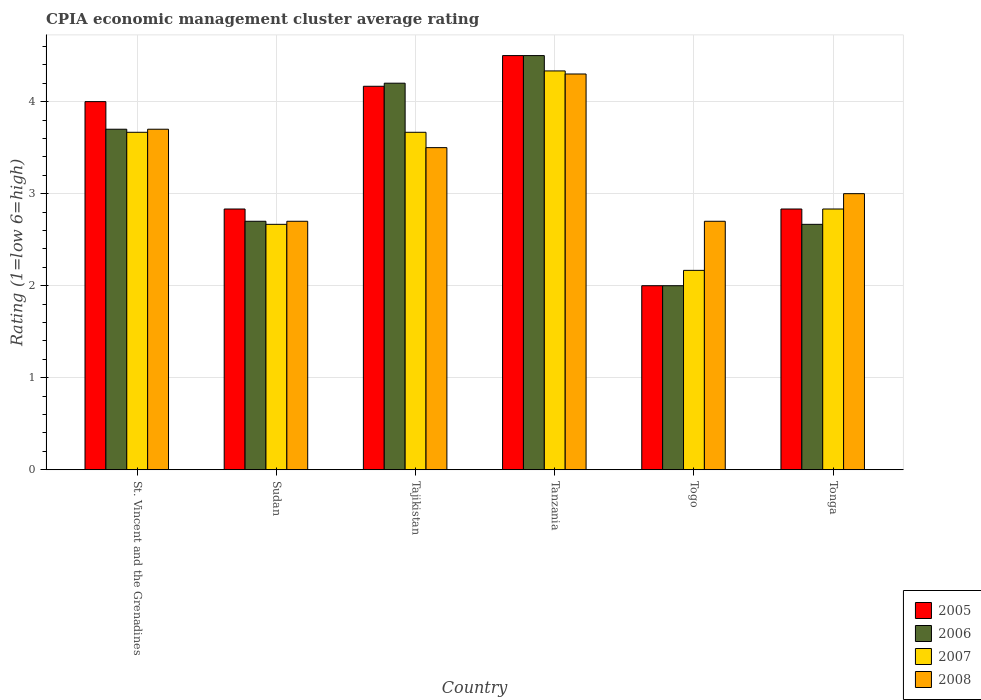How many different coloured bars are there?
Your answer should be compact. 4. How many groups of bars are there?
Offer a very short reply. 6. How many bars are there on the 5th tick from the right?
Your answer should be compact. 4. What is the label of the 5th group of bars from the left?
Provide a short and direct response. Togo. What is the CPIA rating in 2005 in Tonga?
Provide a succinct answer. 2.83. Across all countries, what is the maximum CPIA rating in 2007?
Your response must be concise. 4.33. Across all countries, what is the minimum CPIA rating in 2007?
Your answer should be very brief. 2.17. In which country was the CPIA rating in 2007 maximum?
Offer a terse response. Tanzania. In which country was the CPIA rating in 2008 minimum?
Your answer should be compact. Sudan. What is the total CPIA rating in 2005 in the graph?
Keep it short and to the point. 20.33. What is the difference between the CPIA rating in 2008 in Sudan and that in Tanzania?
Offer a terse response. -1.6. What is the average CPIA rating in 2005 per country?
Offer a terse response. 3.39. What is the difference between the CPIA rating of/in 2007 and CPIA rating of/in 2005 in Togo?
Provide a succinct answer. 0.17. In how many countries, is the CPIA rating in 2006 greater than 2.8?
Offer a very short reply. 3. What is the ratio of the CPIA rating in 2008 in Sudan to that in Tajikistan?
Provide a short and direct response. 0.77. Is the difference between the CPIA rating in 2007 in St. Vincent and the Grenadines and Togo greater than the difference between the CPIA rating in 2005 in St. Vincent and the Grenadines and Togo?
Give a very brief answer. No. What is the difference between the highest and the second highest CPIA rating in 2007?
Your answer should be very brief. -0.67. What is the difference between the highest and the lowest CPIA rating in 2008?
Provide a succinct answer. 1.6. In how many countries, is the CPIA rating in 2005 greater than the average CPIA rating in 2005 taken over all countries?
Your answer should be compact. 3. Is the sum of the CPIA rating in 2008 in Sudan and Tonga greater than the maximum CPIA rating in 2007 across all countries?
Provide a succinct answer. Yes. Is it the case that in every country, the sum of the CPIA rating in 2008 and CPIA rating in 2007 is greater than the sum of CPIA rating in 2005 and CPIA rating in 2006?
Provide a short and direct response. No. What does the 4th bar from the left in Tajikistan represents?
Offer a very short reply. 2008. How many bars are there?
Offer a very short reply. 24. How many legend labels are there?
Provide a short and direct response. 4. What is the title of the graph?
Offer a very short reply. CPIA economic management cluster average rating. Does "2003" appear as one of the legend labels in the graph?
Provide a short and direct response. No. What is the label or title of the X-axis?
Ensure brevity in your answer.  Country. What is the Rating (1=low 6=high) of 2007 in St. Vincent and the Grenadines?
Offer a very short reply. 3.67. What is the Rating (1=low 6=high) of 2005 in Sudan?
Ensure brevity in your answer.  2.83. What is the Rating (1=low 6=high) of 2006 in Sudan?
Your response must be concise. 2.7. What is the Rating (1=low 6=high) in 2007 in Sudan?
Offer a very short reply. 2.67. What is the Rating (1=low 6=high) of 2005 in Tajikistan?
Offer a very short reply. 4.17. What is the Rating (1=low 6=high) of 2006 in Tajikistan?
Provide a succinct answer. 4.2. What is the Rating (1=low 6=high) in 2007 in Tajikistan?
Keep it short and to the point. 3.67. What is the Rating (1=low 6=high) of 2005 in Tanzania?
Your answer should be compact. 4.5. What is the Rating (1=low 6=high) in 2007 in Tanzania?
Your response must be concise. 4.33. What is the Rating (1=low 6=high) in 2006 in Togo?
Your response must be concise. 2. What is the Rating (1=low 6=high) in 2007 in Togo?
Keep it short and to the point. 2.17. What is the Rating (1=low 6=high) in 2008 in Togo?
Make the answer very short. 2.7. What is the Rating (1=low 6=high) in 2005 in Tonga?
Make the answer very short. 2.83. What is the Rating (1=low 6=high) of 2006 in Tonga?
Your answer should be very brief. 2.67. What is the Rating (1=low 6=high) of 2007 in Tonga?
Provide a succinct answer. 2.83. What is the Rating (1=low 6=high) of 2008 in Tonga?
Offer a terse response. 3. Across all countries, what is the maximum Rating (1=low 6=high) of 2005?
Your response must be concise. 4.5. Across all countries, what is the maximum Rating (1=low 6=high) of 2006?
Offer a very short reply. 4.5. Across all countries, what is the maximum Rating (1=low 6=high) in 2007?
Give a very brief answer. 4.33. Across all countries, what is the minimum Rating (1=low 6=high) in 2005?
Offer a very short reply. 2. Across all countries, what is the minimum Rating (1=low 6=high) in 2006?
Offer a very short reply. 2. Across all countries, what is the minimum Rating (1=low 6=high) in 2007?
Make the answer very short. 2.17. What is the total Rating (1=low 6=high) in 2005 in the graph?
Keep it short and to the point. 20.33. What is the total Rating (1=low 6=high) in 2006 in the graph?
Give a very brief answer. 19.77. What is the total Rating (1=low 6=high) of 2007 in the graph?
Ensure brevity in your answer.  19.33. What is the total Rating (1=low 6=high) of 2008 in the graph?
Provide a succinct answer. 19.9. What is the difference between the Rating (1=low 6=high) in 2005 in St. Vincent and the Grenadines and that in Sudan?
Give a very brief answer. 1.17. What is the difference between the Rating (1=low 6=high) of 2006 in St. Vincent and the Grenadines and that in Sudan?
Your answer should be compact. 1. What is the difference between the Rating (1=low 6=high) of 2008 in St. Vincent and the Grenadines and that in Sudan?
Make the answer very short. 1. What is the difference between the Rating (1=low 6=high) of 2005 in St. Vincent and the Grenadines and that in Tajikistan?
Offer a terse response. -0.17. What is the difference between the Rating (1=low 6=high) in 2008 in St. Vincent and the Grenadines and that in Tajikistan?
Offer a terse response. 0.2. What is the difference between the Rating (1=low 6=high) of 2005 in St. Vincent and the Grenadines and that in Tanzania?
Provide a succinct answer. -0.5. What is the difference between the Rating (1=low 6=high) of 2006 in St. Vincent and the Grenadines and that in Tanzania?
Offer a very short reply. -0.8. What is the difference between the Rating (1=low 6=high) in 2007 in St. Vincent and the Grenadines and that in Tanzania?
Your answer should be compact. -0.67. What is the difference between the Rating (1=low 6=high) of 2008 in St. Vincent and the Grenadines and that in Tanzania?
Your answer should be compact. -0.6. What is the difference between the Rating (1=low 6=high) of 2007 in St. Vincent and the Grenadines and that in Togo?
Give a very brief answer. 1.5. What is the difference between the Rating (1=low 6=high) in 2006 in St. Vincent and the Grenadines and that in Tonga?
Keep it short and to the point. 1.03. What is the difference between the Rating (1=low 6=high) in 2005 in Sudan and that in Tajikistan?
Keep it short and to the point. -1.33. What is the difference between the Rating (1=low 6=high) of 2006 in Sudan and that in Tajikistan?
Offer a terse response. -1.5. What is the difference between the Rating (1=low 6=high) in 2007 in Sudan and that in Tajikistan?
Provide a succinct answer. -1. What is the difference between the Rating (1=low 6=high) of 2008 in Sudan and that in Tajikistan?
Give a very brief answer. -0.8. What is the difference between the Rating (1=low 6=high) of 2005 in Sudan and that in Tanzania?
Your answer should be very brief. -1.67. What is the difference between the Rating (1=low 6=high) of 2007 in Sudan and that in Tanzania?
Your response must be concise. -1.67. What is the difference between the Rating (1=low 6=high) in 2008 in Sudan and that in Tanzania?
Your answer should be very brief. -1.6. What is the difference between the Rating (1=low 6=high) in 2007 in Sudan and that in Togo?
Give a very brief answer. 0.5. What is the difference between the Rating (1=low 6=high) of 2008 in Sudan and that in Togo?
Ensure brevity in your answer.  0. What is the difference between the Rating (1=low 6=high) in 2005 in Sudan and that in Tonga?
Offer a very short reply. 0. What is the difference between the Rating (1=low 6=high) in 2006 in Sudan and that in Tonga?
Keep it short and to the point. 0.03. What is the difference between the Rating (1=low 6=high) of 2008 in Sudan and that in Tonga?
Offer a terse response. -0.3. What is the difference between the Rating (1=low 6=high) of 2007 in Tajikistan and that in Tanzania?
Make the answer very short. -0.67. What is the difference between the Rating (1=low 6=high) of 2005 in Tajikistan and that in Togo?
Your answer should be very brief. 2.17. What is the difference between the Rating (1=low 6=high) of 2006 in Tajikistan and that in Togo?
Provide a short and direct response. 2.2. What is the difference between the Rating (1=low 6=high) of 2007 in Tajikistan and that in Togo?
Offer a terse response. 1.5. What is the difference between the Rating (1=low 6=high) of 2008 in Tajikistan and that in Togo?
Provide a short and direct response. 0.8. What is the difference between the Rating (1=low 6=high) in 2006 in Tajikistan and that in Tonga?
Your response must be concise. 1.53. What is the difference between the Rating (1=low 6=high) of 2008 in Tajikistan and that in Tonga?
Ensure brevity in your answer.  0.5. What is the difference between the Rating (1=low 6=high) in 2005 in Tanzania and that in Togo?
Your answer should be compact. 2.5. What is the difference between the Rating (1=low 6=high) of 2006 in Tanzania and that in Togo?
Offer a very short reply. 2.5. What is the difference between the Rating (1=low 6=high) in 2007 in Tanzania and that in Togo?
Provide a succinct answer. 2.17. What is the difference between the Rating (1=low 6=high) in 2005 in Tanzania and that in Tonga?
Your answer should be very brief. 1.67. What is the difference between the Rating (1=low 6=high) of 2006 in Tanzania and that in Tonga?
Give a very brief answer. 1.83. What is the difference between the Rating (1=low 6=high) in 2007 in Tanzania and that in Tonga?
Give a very brief answer. 1.5. What is the difference between the Rating (1=low 6=high) of 2008 in Tanzania and that in Tonga?
Provide a short and direct response. 1.3. What is the difference between the Rating (1=low 6=high) of 2007 in Togo and that in Tonga?
Keep it short and to the point. -0.67. What is the difference between the Rating (1=low 6=high) in 2008 in Togo and that in Tonga?
Provide a succinct answer. -0.3. What is the difference between the Rating (1=low 6=high) in 2007 in St. Vincent and the Grenadines and the Rating (1=low 6=high) in 2008 in Sudan?
Make the answer very short. 0.97. What is the difference between the Rating (1=low 6=high) of 2005 in St. Vincent and the Grenadines and the Rating (1=low 6=high) of 2006 in Tajikistan?
Offer a very short reply. -0.2. What is the difference between the Rating (1=low 6=high) of 2005 in St. Vincent and the Grenadines and the Rating (1=low 6=high) of 2008 in Tajikistan?
Offer a terse response. 0.5. What is the difference between the Rating (1=low 6=high) of 2006 in St. Vincent and the Grenadines and the Rating (1=low 6=high) of 2007 in Tajikistan?
Provide a short and direct response. 0.03. What is the difference between the Rating (1=low 6=high) in 2006 in St. Vincent and the Grenadines and the Rating (1=low 6=high) in 2008 in Tajikistan?
Give a very brief answer. 0.2. What is the difference between the Rating (1=low 6=high) of 2007 in St. Vincent and the Grenadines and the Rating (1=low 6=high) of 2008 in Tajikistan?
Your answer should be compact. 0.17. What is the difference between the Rating (1=low 6=high) in 2005 in St. Vincent and the Grenadines and the Rating (1=low 6=high) in 2007 in Tanzania?
Your answer should be very brief. -0.33. What is the difference between the Rating (1=low 6=high) of 2006 in St. Vincent and the Grenadines and the Rating (1=low 6=high) of 2007 in Tanzania?
Provide a short and direct response. -0.63. What is the difference between the Rating (1=low 6=high) of 2007 in St. Vincent and the Grenadines and the Rating (1=low 6=high) of 2008 in Tanzania?
Offer a very short reply. -0.63. What is the difference between the Rating (1=low 6=high) in 2005 in St. Vincent and the Grenadines and the Rating (1=low 6=high) in 2007 in Togo?
Keep it short and to the point. 1.83. What is the difference between the Rating (1=low 6=high) in 2006 in St. Vincent and the Grenadines and the Rating (1=low 6=high) in 2007 in Togo?
Provide a short and direct response. 1.53. What is the difference between the Rating (1=low 6=high) of 2006 in St. Vincent and the Grenadines and the Rating (1=low 6=high) of 2008 in Togo?
Provide a short and direct response. 1. What is the difference between the Rating (1=low 6=high) in 2007 in St. Vincent and the Grenadines and the Rating (1=low 6=high) in 2008 in Togo?
Offer a very short reply. 0.97. What is the difference between the Rating (1=low 6=high) of 2005 in St. Vincent and the Grenadines and the Rating (1=low 6=high) of 2006 in Tonga?
Ensure brevity in your answer.  1.33. What is the difference between the Rating (1=low 6=high) of 2005 in St. Vincent and the Grenadines and the Rating (1=low 6=high) of 2008 in Tonga?
Offer a very short reply. 1. What is the difference between the Rating (1=low 6=high) of 2006 in St. Vincent and the Grenadines and the Rating (1=low 6=high) of 2007 in Tonga?
Your answer should be compact. 0.87. What is the difference between the Rating (1=low 6=high) in 2006 in St. Vincent and the Grenadines and the Rating (1=low 6=high) in 2008 in Tonga?
Provide a succinct answer. 0.7. What is the difference between the Rating (1=low 6=high) of 2005 in Sudan and the Rating (1=low 6=high) of 2006 in Tajikistan?
Keep it short and to the point. -1.37. What is the difference between the Rating (1=low 6=high) in 2005 in Sudan and the Rating (1=low 6=high) in 2007 in Tajikistan?
Give a very brief answer. -0.83. What is the difference between the Rating (1=low 6=high) in 2005 in Sudan and the Rating (1=low 6=high) in 2008 in Tajikistan?
Provide a short and direct response. -0.67. What is the difference between the Rating (1=low 6=high) of 2006 in Sudan and the Rating (1=low 6=high) of 2007 in Tajikistan?
Offer a very short reply. -0.97. What is the difference between the Rating (1=low 6=high) in 2006 in Sudan and the Rating (1=low 6=high) in 2008 in Tajikistan?
Provide a short and direct response. -0.8. What is the difference between the Rating (1=low 6=high) in 2007 in Sudan and the Rating (1=low 6=high) in 2008 in Tajikistan?
Your response must be concise. -0.83. What is the difference between the Rating (1=low 6=high) of 2005 in Sudan and the Rating (1=low 6=high) of 2006 in Tanzania?
Your response must be concise. -1.67. What is the difference between the Rating (1=low 6=high) in 2005 in Sudan and the Rating (1=low 6=high) in 2008 in Tanzania?
Offer a terse response. -1.47. What is the difference between the Rating (1=low 6=high) in 2006 in Sudan and the Rating (1=low 6=high) in 2007 in Tanzania?
Your answer should be compact. -1.63. What is the difference between the Rating (1=low 6=high) in 2006 in Sudan and the Rating (1=low 6=high) in 2008 in Tanzania?
Your answer should be compact. -1.6. What is the difference between the Rating (1=low 6=high) of 2007 in Sudan and the Rating (1=low 6=high) of 2008 in Tanzania?
Offer a very short reply. -1.63. What is the difference between the Rating (1=low 6=high) in 2005 in Sudan and the Rating (1=low 6=high) in 2006 in Togo?
Provide a succinct answer. 0.83. What is the difference between the Rating (1=low 6=high) in 2005 in Sudan and the Rating (1=low 6=high) in 2008 in Togo?
Your answer should be very brief. 0.13. What is the difference between the Rating (1=low 6=high) of 2006 in Sudan and the Rating (1=low 6=high) of 2007 in Togo?
Give a very brief answer. 0.53. What is the difference between the Rating (1=low 6=high) of 2006 in Sudan and the Rating (1=low 6=high) of 2008 in Togo?
Your answer should be very brief. 0. What is the difference between the Rating (1=low 6=high) in 2007 in Sudan and the Rating (1=low 6=high) in 2008 in Togo?
Ensure brevity in your answer.  -0.03. What is the difference between the Rating (1=low 6=high) of 2006 in Sudan and the Rating (1=low 6=high) of 2007 in Tonga?
Offer a terse response. -0.13. What is the difference between the Rating (1=low 6=high) of 2006 in Sudan and the Rating (1=low 6=high) of 2008 in Tonga?
Offer a very short reply. -0.3. What is the difference between the Rating (1=low 6=high) of 2007 in Sudan and the Rating (1=low 6=high) of 2008 in Tonga?
Offer a very short reply. -0.33. What is the difference between the Rating (1=low 6=high) of 2005 in Tajikistan and the Rating (1=low 6=high) of 2007 in Tanzania?
Give a very brief answer. -0.17. What is the difference between the Rating (1=low 6=high) of 2005 in Tajikistan and the Rating (1=low 6=high) of 2008 in Tanzania?
Provide a succinct answer. -0.13. What is the difference between the Rating (1=low 6=high) of 2006 in Tajikistan and the Rating (1=low 6=high) of 2007 in Tanzania?
Offer a very short reply. -0.13. What is the difference between the Rating (1=low 6=high) of 2006 in Tajikistan and the Rating (1=low 6=high) of 2008 in Tanzania?
Provide a short and direct response. -0.1. What is the difference between the Rating (1=low 6=high) in 2007 in Tajikistan and the Rating (1=low 6=high) in 2008 in Tanzania?
Ensure brevity in your answer.  -0.63. What is the difference between the Rating (1=low 6=high) of 2005 in Tajikistan and the Rating (1=low 6=high) of 2006 in Togo?
Your answer should be very brief. 2.17. What is the difference between the Rating (1=low 6=high) in 2005 in Tajikistan and the Rating (1=low 6=high) in 2008 in Togo?
Provide a short and direct response. 1.47. What is the difference between the Rating (1=low 6=high) in 2006 in Tajikistan and the Rating (1=low 6=high) in 2007 in Togo?
Offer a very short reply. 2.03. What is the difference between the Rating (1=low 6=high) in 2006 in Tajikistan and the Rating (1=low 6=high) in 2008 in Togo?
Give a very brief answer. 1.5. What is the difference between the Rating (1=low 6=high) of 2007 in Tajikistan and the Rating (1=low 6=high) of 2008 in Togo?
Offer a terse response. 0.97. What is the difference between the Rating (1=low 6=high) of 2005 in Tajikistan and the Rating (1=low 6=high) of 2006 in Tonga?
Your response must be concise. 1.5. What is the difference between the Rating (1=low 6=high) of 2006 in Tajikistan and the Rating (1=low 6=high) of 2007 in Tonga?
Ensure brevity in your answer.  1.37. What is the difference between the Rating (1=low 6=high) in 2005 in Tanzania and the Rating (1=low 6=high) in 2006 in Togo?
Your response must be concise. 2.5. What is the difference between the Rating (1=low 6=high) in 2005 in Tanzania and the Rating (1=low 6=high) in 2007 in Togo?
Give a very brief answer. 2.33. What is the difference between the Rating (1=low 6=high) of 2005 in Tanzania and the Rating (1=low 6=high) of 2008 in Togo?
Make the answer very short. 1.8. What is the difference between the Rating (1=low 6=high) of 2006 in Tanzania and the Rating (1=low 6=high) of 2007 in Togo?
Give a very brief answer. 2.33. What is the difference between the Rating (1=low 6=high) of 2006 in Tanzania and the Rating (1=low 6=high) of 2008 in Togo?
Make the answer very short. 1.8. What is the difference between the Rating (1=low 6=high) of 2007 in Tanzania and the Rating (1=low 6=high) of 2008 in Togo?
Provide a short and direct response. 1.63. What is the difference between the Rating (1=low 6=high) in 2005 in Tanzania and the Rating (1=low 6=high) in 2006 in Tonga?
Give a very brief answer. 1.83. What is the difference between the Rating (1=low 6=high) of 2006 in Tanzania and the Rating (1=low 6=high) of 2007 in Tonga?
Offer a terse response. 1.67. What is the difference between the Rating (1=low 6=high) in 2006 in Tanzania and the Rating (1=low 6=high) in 2008 in Tonga?
Give a very brief answer. 1.5. What is the difference between the Rating (1=low 6=high) in 2007 in Tanzania and the Rating (1=low 6=high) in 2008 in Tonga?
Ensure brevity in your answer.  1.33. What is the difference between the Rating (1=low 6=high) in 2006 in Togo and the Rating (1=low 6=high) in 2008 in Tonga?
Provide a short and direct response. -1. What is the difference between the Rating (1=low 6=high) of 2007 in Togo and the Rating (1=low 6=high) of 2008 in Tonga?
Your response must be concise. -0.83. What is the average Rating (1=low 6=high) in 2005 per country?
Your answer should be compact. 3.39. What is the average Rating (1=low 6=high) in 2006 per country?
Make the answer very short. 3.29. What is the average Rating (1=low 6=high) of 2007 per country?
Give a very brief answer. 3.22. What is the average Rating (1=low 6=high) in 2008 per country?
Your answer should be very brief. 3.32. What is the difference between the Rating (1=low 6=high) of 2005 and Rating (1=low 6=high) of 2006 in St. Vincent and the Grenadines?
Offer a very short reply. 0.3. What is the difference between the Rating (1=low 6=high) in 2005 and Rating (1=low 6=high) in 2007 in St. Vincent and the Grenadines?
Keep it short and to the point. 0.33. What is the difference between the Rating (1=low 6=high) in 2007 and Rating (1=low 6=high) in 2008 in St. Vincent and the Grenadines?
Provide a succinct answer. -0.03. What is the difference between the Rating (1=low 6=high) in 2005 and Rating (1=low 6=high) in 2006 in Sudan?
Your answer should be compact. 0.13. What is the difference between the Rating (1=low 6=high) in 2005 and Rating (1=low 6=high) in 2008 in Sudan?
Ensure brevity in your answer.  0.13. What is the difference between the Rating (1=low 6=high) in 2006 and Rating (1=low 6=high) in 2008 in Sudan?
Keep it short and to the point. 0. What is the difference between the Rating (1=low 6=high) of 2007 and Rating (1=low 6=high) of 2008 in Sudan?
Keep it short and to the point. -0.03. What is the difference between the Rating (1=low 6=high) of 2005 and Rating (1=low 6=high) of 2006 in Tajikistan?
Offer a very short reply. -0.03. What is the difference between the Rating (1=low 6=high) of 2006 and Rating (1=low 6=high) of 2007 in Tajikistan?
Your response must be concise. 0.53. What is the difference between the Rating (1=low 6=high) of 2007 and Rating (1=low 6=high) of 2008 in Tajikistan?
Provide a succinct answer. 0.17. What is the difference between the Rating (1=low 6=high) in 2005 and Rating (1=low 6=high) in 2008 in Tanzania?
Offer a terse response. 0.2. What is the difference between the Rating (1=low 6=high) of 2006 and Rating (1=low 6=high) of 2008 in Tanzania?
Your answer should be compact. 0.2. What is the difference between the Rating (1=low 6=high) in 2005 and Rating (1=low 6=high) in 2006 in Togo?
Provide a short and direct response. 0. What is the difference between the Rating (1=low 6=high) of 2005 and Rating (1=low 6=high) of 2008 in Togo?
Ensure brevity in your answer.  -0.7. What is the difference between the Rating (1=low 6=high) of 2006 and Rating (1=low 6=high) of 2007 in Togo?
Offer a very short reply. -0.17. What is the difference between the Rating (1=low 6=high) in 2007 and Rating (1=low 6=high) in 2008 in Togo?
Keep it short and to the point. -0.53. What is the difference between the Rating (1=low 6=high) of 2005 and Rating (1=low 6=high) of 2006 in Tonga?
Offer a terse response. 0.17. What is the difference between the Rating (1=low 6=high) of 2006 and Rating (1=low 6=high) of 2007 in Tonga?
Make the answer very short. -0.17. What is the ratio of the Rating (1=low 6=high) in 2005 in St. Vincent and the Grenadines to that in Sudan?
Your response must be concise. 1.41. What is the ratio of the Rating (1=low 6=high) of 2006 in St. Vincent and the Grenadines to that in Sudan?
Your answer should be compact. 1.37. What is the ratio of the Rating (1=low 6=high) in 2007 in St. Vincent and the Grenadines to that in Sudan?
Give a very brief answer. 1.38. What is the ratio of the Rating (1=low 6=high) of 2008 in St. Vincent and the Grenadines to that in Sudan?
Your answer should be very brief. 1.37. What is the ratio of the Rating (1=low 6=high) of 2005 in St. Vincent and the Grenadines to that in Tajikistan?
Provide a succinct answer. 0.96. What is the ratio of the Rating (1=low 6=high) in 2006 in St. Vincent and the Grenadines to that in Tajikistan?
Make the answer very short. 0.88. What is the ratio of the Rating (1=low 6=high) of 2008 in St. Vincent and the Grenadines to that in Tajikistan?
Your answer should be very brief. 1.06. What is the ratio of the Rating (1=low 6=high) in 2005 in St. Vincent and the Grenadines to that in Tanzania?
Keep it short and to the point. 0.89. What is the ratio of the Rating (1=low 6=high) of 2006 in St. Vincent and the Grenadines to that in Tanzania?
Your answer should be compact. 0.82. What is the ratio of the Rating (1=low 6=high) of 2007 in St. Vincent and the Grenadines to that in Tanzania?
Offer a very short reply. 0.85. What is the ratio of the Rating (1=low 6=high) in 2008 in St. Vincent and the Grenadines to that in Tanzania?
Provide a short and direct response. 0.86. What is the ratio of the Rating (1=low 6=high) of 2006 in St. Vincent and the Grenadines to that in Togo?
Ensure brevity in your answer.  1.85. What is the ratio of the Rating (1=low 6=high) of 2007 in St. Vincent and the Grenadines to that in Togo?
Provide a succinct answer. 1.69. What is the ratio of the Rating (1=low 6=high) in 2008 in St. Vincent and the Grenadines to that in Togo?
Offer a very short reply. 1.37. What is the ratio of the Rating (1=low 6=high) of 2005 in St. Vincent and the Grenadines to that in Tonga?
Offer a very short reply. 1.41. What is the ratio of the Rating (1=low 6=high) in 2006 in St. Vincent and the Grenadines to that in Tonga?
Ensure brevity in your answer.  1.39. What is the ratio of the Rating (1=low 6=high) of 2007 in St. Vincent and the Grenadines to that in Tonga?
Your answer should be very brief. 1.29. What is the ratio of the Rating (1=low 6=high) of 2008 in St. Vincent and the Grenadines to that in Tonga?
Your answer should be compact. 1.23. What is the ratio of the Rating (1=low 6=high) in 2005 in Sudan to that in Tajikistan?
Provide a succinct answer. 0.68. What is the ratio of the Rating (1=low 6=high) of 2006 in Sudan to that in Tajikistan?
Offer a very short reply. 0.64. What is the ratio of the Rating (1=low 6=high) in 2007 in Sudan to that in Tajikistan?
Offer a terse response. 0.73. What is the ratio of the Rating (1=low 6=high) of 2008 in Sudan to that in Tajikistan?
Give a very brief answer. 0.77. What is the ratio of the Rating (1=low 6=high) in 2005 in Sudan to that in Tanzania?
Offer a very short reply. 0.63. What is the ratio of the Rating (1=low 6=high) in 2007 in Sudan to that in Tanzania?
Your answer should be compact. 0.62. What is the ratio of the Rating (1=low 6=high) in 2008 in Sudan to that in Tanzania?
Offer a very short reply. 0.63. What is the ratio of the Rating (1=low 6=high) in 2005 in Sudan to that in Togo?
Your response must be concise. 1.42. What is the ratio of the Rating (1=low 6=high) in 2006 in Sudan to that in Togo?
Your answer should be compact. 1.35. What is the ratio of the Rating (1=low 6=high) in 2007 in Sudan to that in Togo?
Your response must be concise. 1.23. What is the ratio of the Rating (1=low 6=high) in 2008 in Sudan to that in Togo?
Make the answer very short. 1. What is the ratio of the Rating (1=low 6=high) in 2005 in Sudan to that in Tonga?
Make the answer very short. 1. What is the ratio of the Rating (1=low 6=high) of 2006 in Sudan to that in Tonga?
Your answer should be compact. 1.01. What is the ratio of the Rating (1=low 6=high) of 2007 in Sudan to that in Tonga?
Your response must be concise. 0.94. What is the ratio of the Rating (1=low 6=high) in 2008 in Sudan to that in Tonga?
Make the answer very short. 0.9. What is the ratio of the Rating (1=low 6=high) of 2005 in Tajikistan to that in Tanzania?
Keep it short and to the point. 0.93. What is the ratio of the Rating (1=low 6=high) of 2006 in Tajikistan to that in Tanzania?
Offer a very short reply. 0.93. What is the ratio of the Rating (1=low 6=high) in 2007 in Tajikistan to that in Tanzania?
Your response must be concise. 0.85. What is the ratio of the Rating (1=low 6=high) in 2008 in Tajikistan to that in Tanzania?
Make the answer very short. 0.81. What is the ratio of the Rating (1=low 6=high) in 2005 in Tajikistan to that in Togo?
Provide a succinct answer. 2.08. What is the ratio of the Rating (1=low 6=high) in 2006 in Tajikistan to that in Togo?
Provide a short and direct response. 2.1. What is the ratio of the Rating (1=low 6=high) of 2007 in Tajikistan to that in Togo?
Give a very brief answer. 1.69. What is the ratio of the Rating (1=low 6=high) of 2008 in Tajikistan to that in Togo?
Offer a very short reply. 1.3. What is the ratio of the Rating (1=low 6=high) of 2005 in Tajikistan to that in Tonga?
Your answer should be very brief. 1.47. What is the ratio of the Rating (1=low 6=high) of 2006 in Tajikistan to that in Tonga?
Offer a terse response. 1.57. What is the ratio of the Rating (1=low 6=high) in 2007 in Tajikistan to that in Tonga?
Your response must be concise. 1.29. What is the ratio of the Rating (1=low 6=high) of 2008 in Tajikistan to that in Tonga?
Offer a very short reply. 1.17. What is the ratio of the Rating (1=low 6=high) of 2005 in Tanzania to that in Togo?
Ensure brevity in your answer.  2.25. What is the ratio of the Rating (1=low 6=high) of 2006 in Tanzania to that in Togo?
Your response must be concise. 2.25. What is the ratio of the Rating (1=low 6=high) of 2007 in Tanzania to that in Togo?
Ensure brevity in your answer.  2. What is the ratio of the Rating (1=low 6=high) of 2008 in Tanzania to that in Togo?
Ensure brevity in your answer.  1.59. What is the ratio of the Rating (1=low 6=high) in 2005 in Tanzania to that in Tonga?
Offer a very short reply. 1.59. What is the ratio of the Rating (1=low 6=high) of 2006 in Tanzania to that in Tonga?
Offer a very short reply. 1.69. What is the ratio of the Rating (1=low 6=high) of 2007 in Tanzania to that in Tonga?
Provide a succinct answer. 1.53. What is the ratio of the Rating (1=low 6=high) in 2008 in Tanzania to that in Tonga?
Ensure brevity in your answer.  1.43. What is the ratio of the Rating (1=low 6=high) of 2005 in Togo to that in Tonga?
Offer a very short reply. 0.71. What is the ratio of the Rating (1=low 6=high) in 2007 in Togo to that in Tonga?
Provide a succinct answer. 0.76. What is the difference between the highest and the second highest Rating (1=low 6=high) in 2005?
Give a very brief answer. 0.33. What is the difference between the highest and the lowest Rating (1=low 6=high) of 2005?
Keep it short and to the point. 2.5. What is the difference between the highest and the lowest Rating (1=low 6=high) of 2006?
Ensure brevity in your answer.  2.5. What is the difference between the highest and the lowest Rating (1=low 6=high) in 2007?
Your response must be concise. 2.17. 